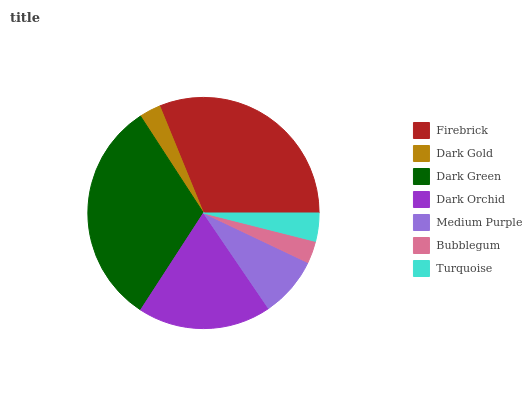Is Dark Gold the minimum?
Answer yes or no. Yes. Is Dark Green the maximum?
Answer yes or no. Yes. Is Dark Green the minimum?
Answer yes or no. No. Is Dark Gold the maximum?
Answer yes or no. No. Is Dark Green greater than Dark Gold?
Answer yes or no. Yes. Is Dark Gold less than Dark Green?
Answer yes or no. Yes. Is Dark Gold greater than Dark Green?
Answer yes or no. No. Is Dark Green less than Dark Gold?
Answer yes or no. No. Is Medium Purple the high median?
Answer yes or no. Yes. Is Medium Purple the low median?
Answer yes or no. Yes. Is Dark Orchid the high median?
Answer yes or no. No. Is Dark Orchid the low median?
Answer yes or no. No. 